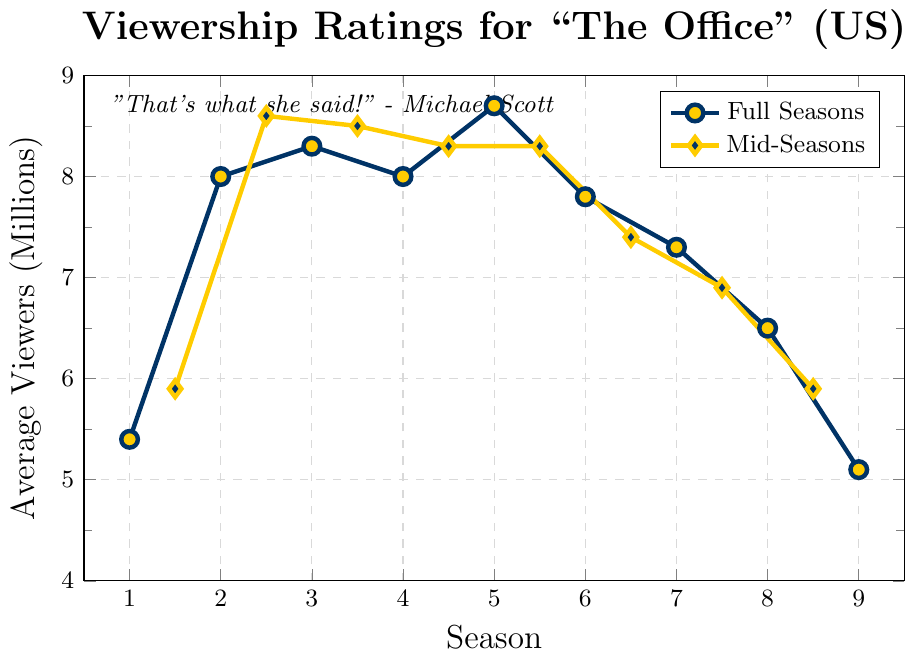Which season had the highest average viewership in millions? From the plot, you can see that Season 5 had the highest point, which indicates the highest average viewership.
Answer: Season 5 What’s the difference in average viewership between Season 1 and Season 9? From the plot, the average viewership for Season 1 is 5.4 million and for Season 9 is 5.1 million. The difference is 5.4 - 5.1 = 0.3 million.
Answer: 0.3 million During which mid-season point did the viewership peak? Observing the mid-seasons represented by diamond markers, the highest point is at mid-Season 2.5.
Answer: Mid-Season 2.5 How does the viewership trend from Season 3 to Season 5 compare to the trend from Season 6 to Season 9? From Season 3 to Season 5, the viewership shows a generally increasing trend, culminating in a peak. From Season 6 to Season 9, there’s a clear decreasing trend.
Answer: Increasing trend (Season 3-5), Decreasing trend (Season 6-9) Which season showed the greatest drop in average viewership from its previous season? The largest drop is between Seasons 8 (6.5 million) and 9 (5.1 million); the difference is 1.4 million.
Answer: Between Seasons 8 and 9 What is the overall average viewership for all full seasons combined? Summing the viewership of full seasons: (5.4 + 8.0 + 8.3 + 8.0 + 8.7 + 7.8 + 7.3 + 6.5 + 5.1) = 65.1. There are 9 full seasons, so the average is 65.1 / 9 ≈ 7.23 million.
Answer: 7.23 million Compare the average viewership of mid-Season 7.5 to full Season 7. For mid-Season 7.5, the viewership is 6.9 million. For full Season 7, the viewership is 7.3 million. Therefore, full Season 7 has higher average viewership.
Answer: Full Season 7 has higher viewership What is the average viewership across all mid-seasons? Summing the mid-seasons: (5.9 + 8.6 + 8.5 + 8.3 + 8.3 + 7.4 + 6.9 + 5.9) = 59.8. There are 8 mid-seasons, so the average is 59.8 / 8 ≈ 7.475 million.
Answer: 7.475 million Which mid-season had the lowest average viewership and what was it? Observing the mid-season points represented by the diamond markers, the lowest viewership is at mid-Season 9.5 with 5.9 million.
Answer: Mid-Season 8.5, 5.9 million 